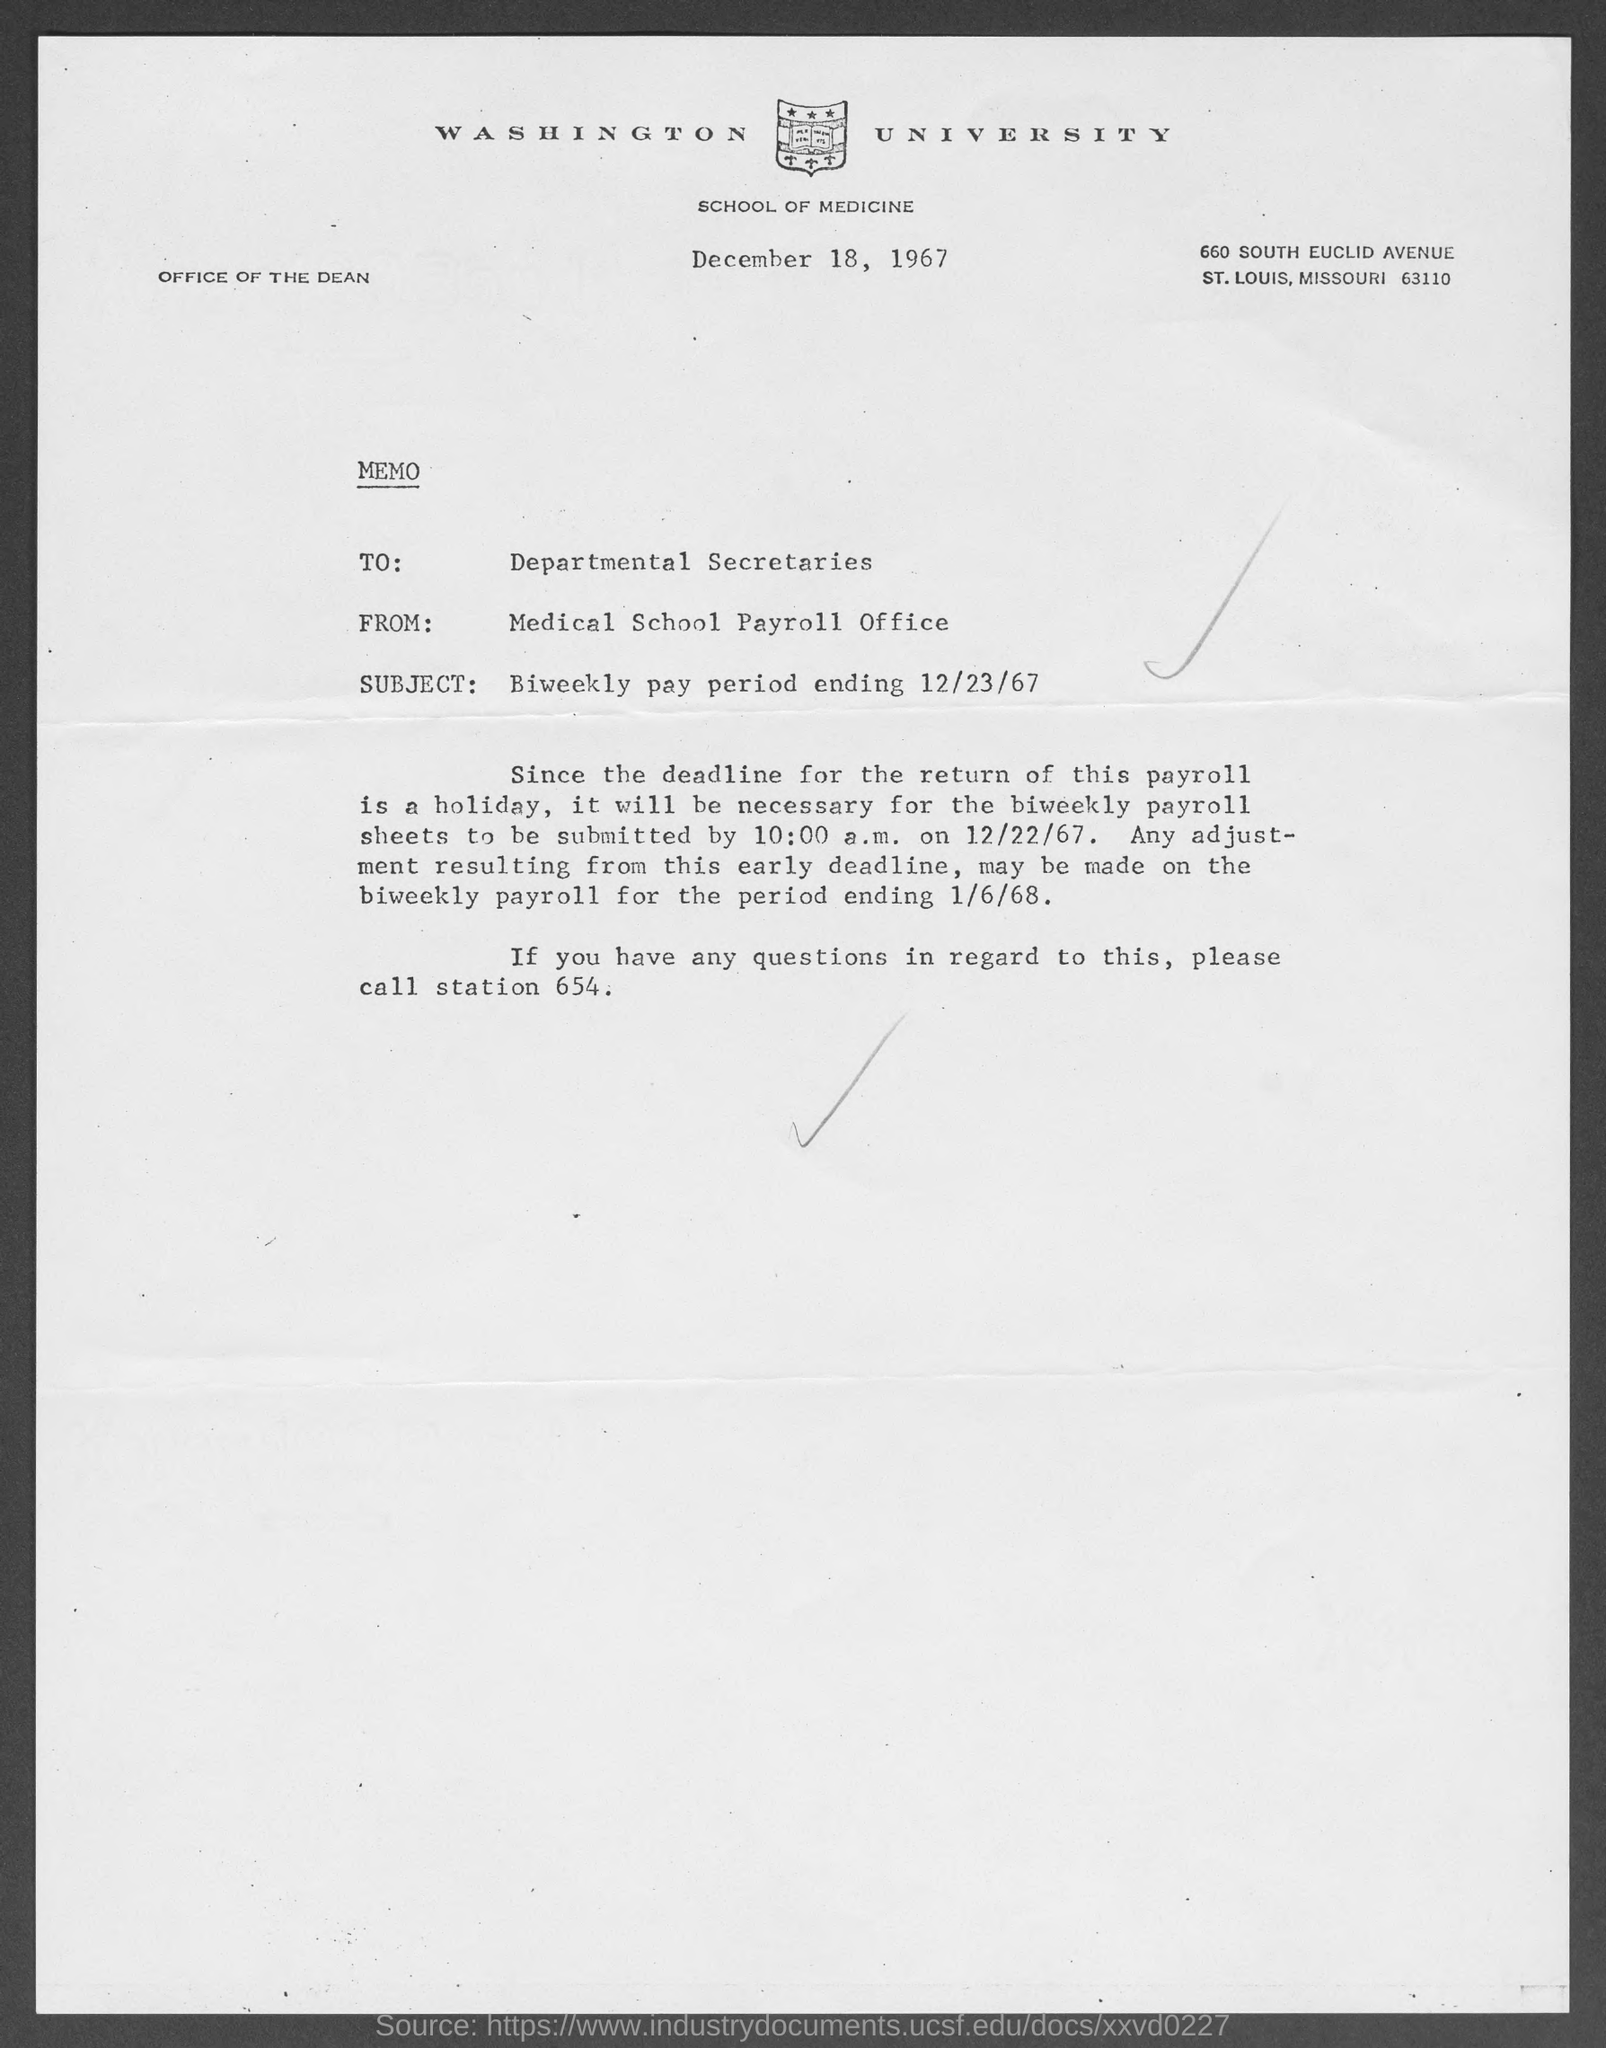Which University is mentioned in the letter head?
Give a very brief answer. Washington University. What is the issued date of this memo?
Keep it short and to the point. December 18, 1967. Who is the sender of this memo?
Make the answer very short. Medical School Payroll Office. To whom, the memo is addressed?
Your answer should be very brief. Departmental Secretaries. What is the subject mentioned in the memo?
Your answer should be very brief. Biweekly pay period ending 12/23/67. 